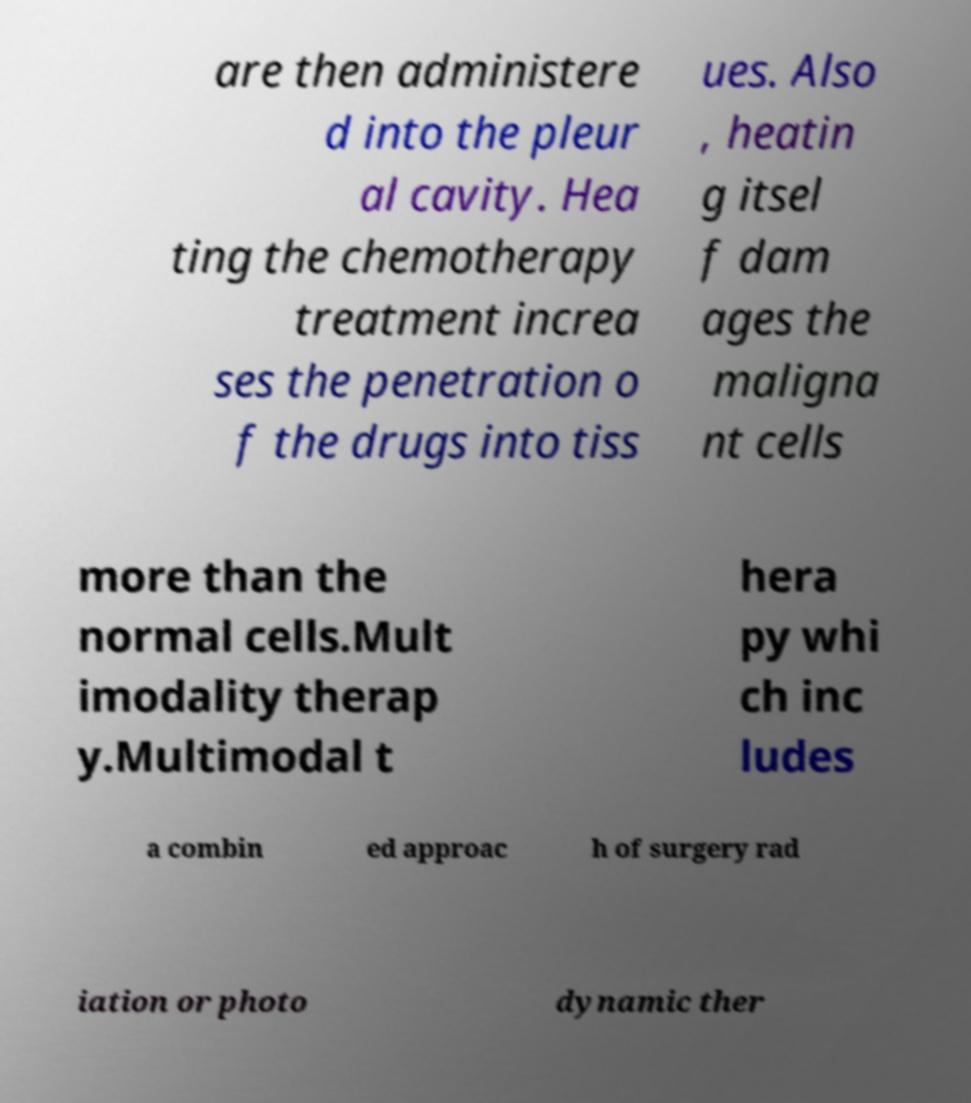Can you accurately transcribe the text from the provided image for me? are then administere d into the pleur al cavity. Hea ting the chemotherapy treatment increa ses the penetration o f the drugs into tiss ues. Also , heatin g itsel f dam ages the maligna nt cells more than the normal cells.Mult imodality therap y.Multimodal t hera py whi ch inc ludes a combin ed approac h of surgery rad iation or photo dynamic ther 